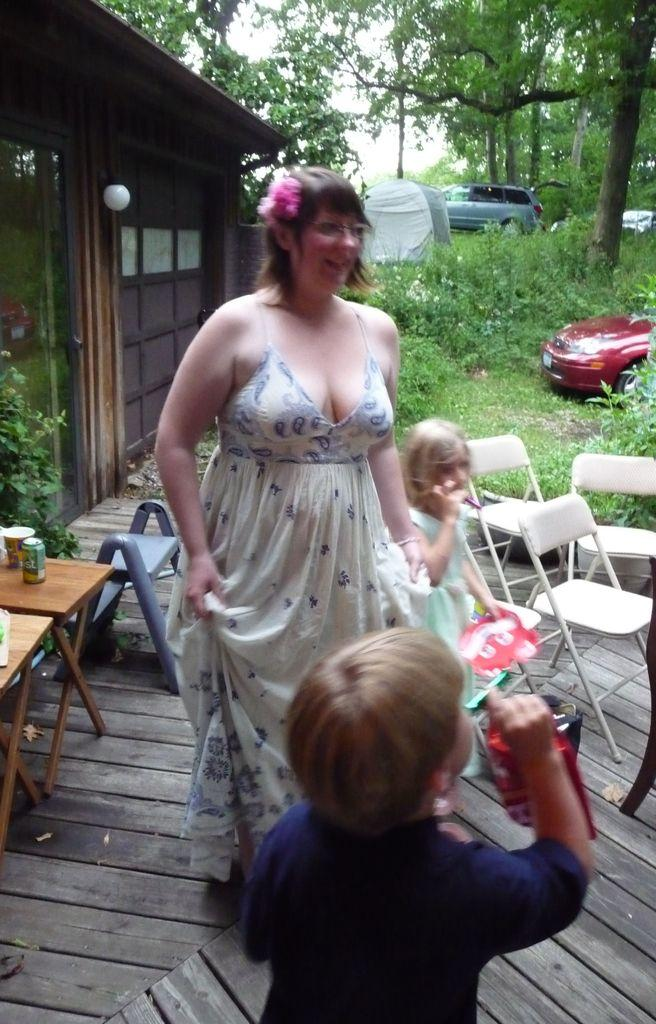What is happening in the image? There are people standing in the image. What can be seen in the background of the image? There are chairs, trees, and vehicles in the background of the image. Are there any pets visible in the image? There are no pets visible in the image. What type of police presence can be seen in the image? There is no police presence in the image. 